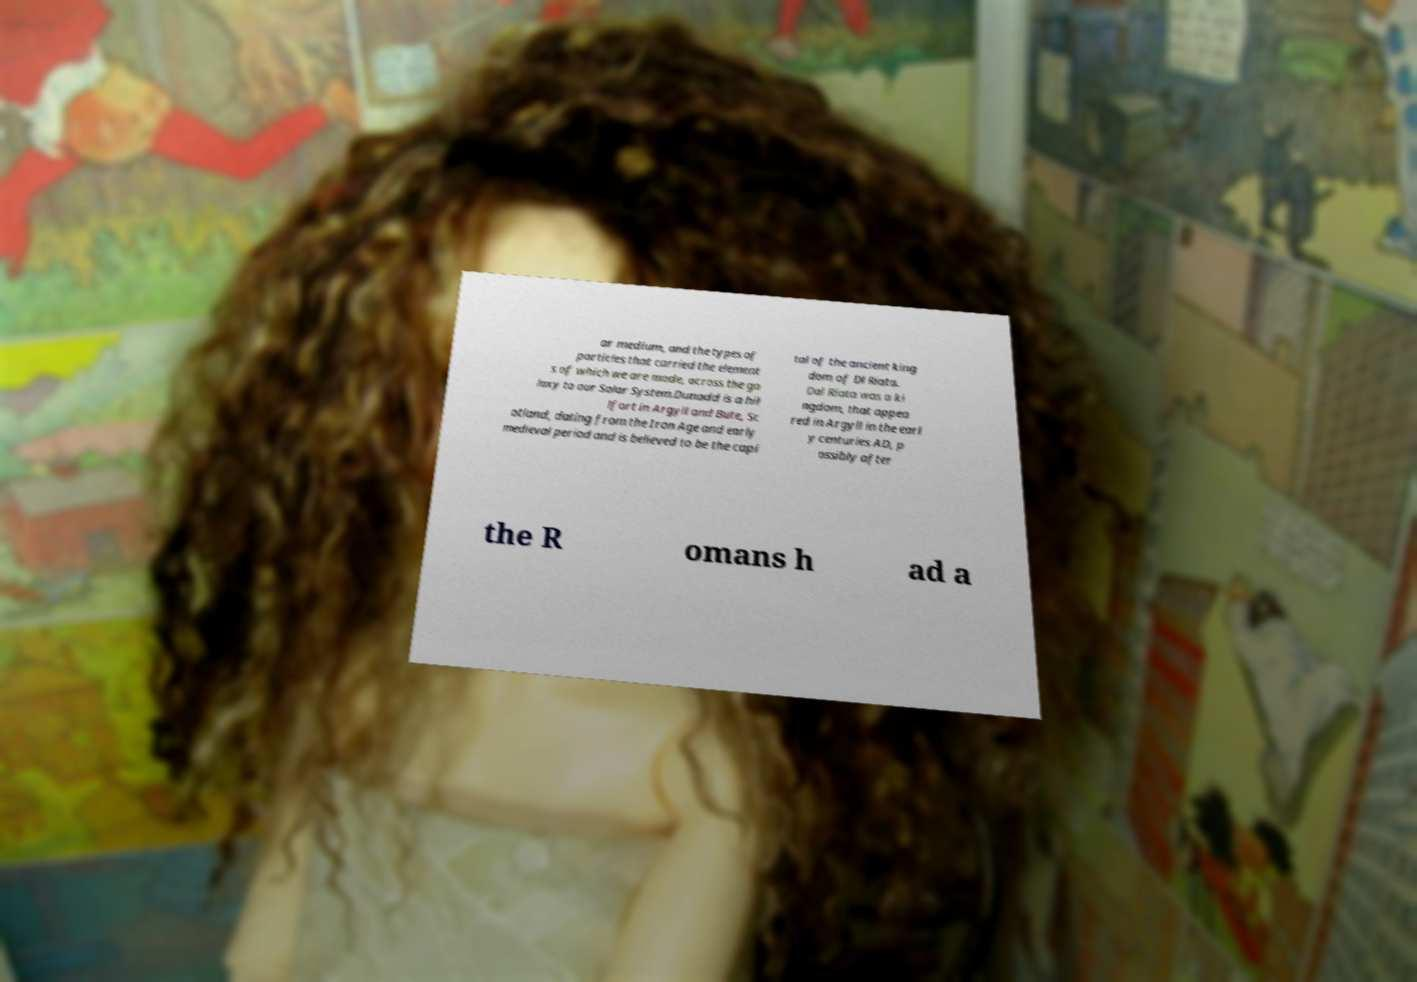Can you accurately transcribe the text from the provided image for me? ar medium, and the types of particles that carried the element s of which we are made, across the ga laxy to our Solar System.Dunadd is a hil lfort in Argyll and Bute, Sc otland, dating from the Iron Age and early medieval period and is believed to be the capi tal of the ancient king dom of Dl Riata. Dal Riata was a ki ngdom, that appea red in Argyll in the earl y centuries AD, p ossibly after the R omans h ad a 